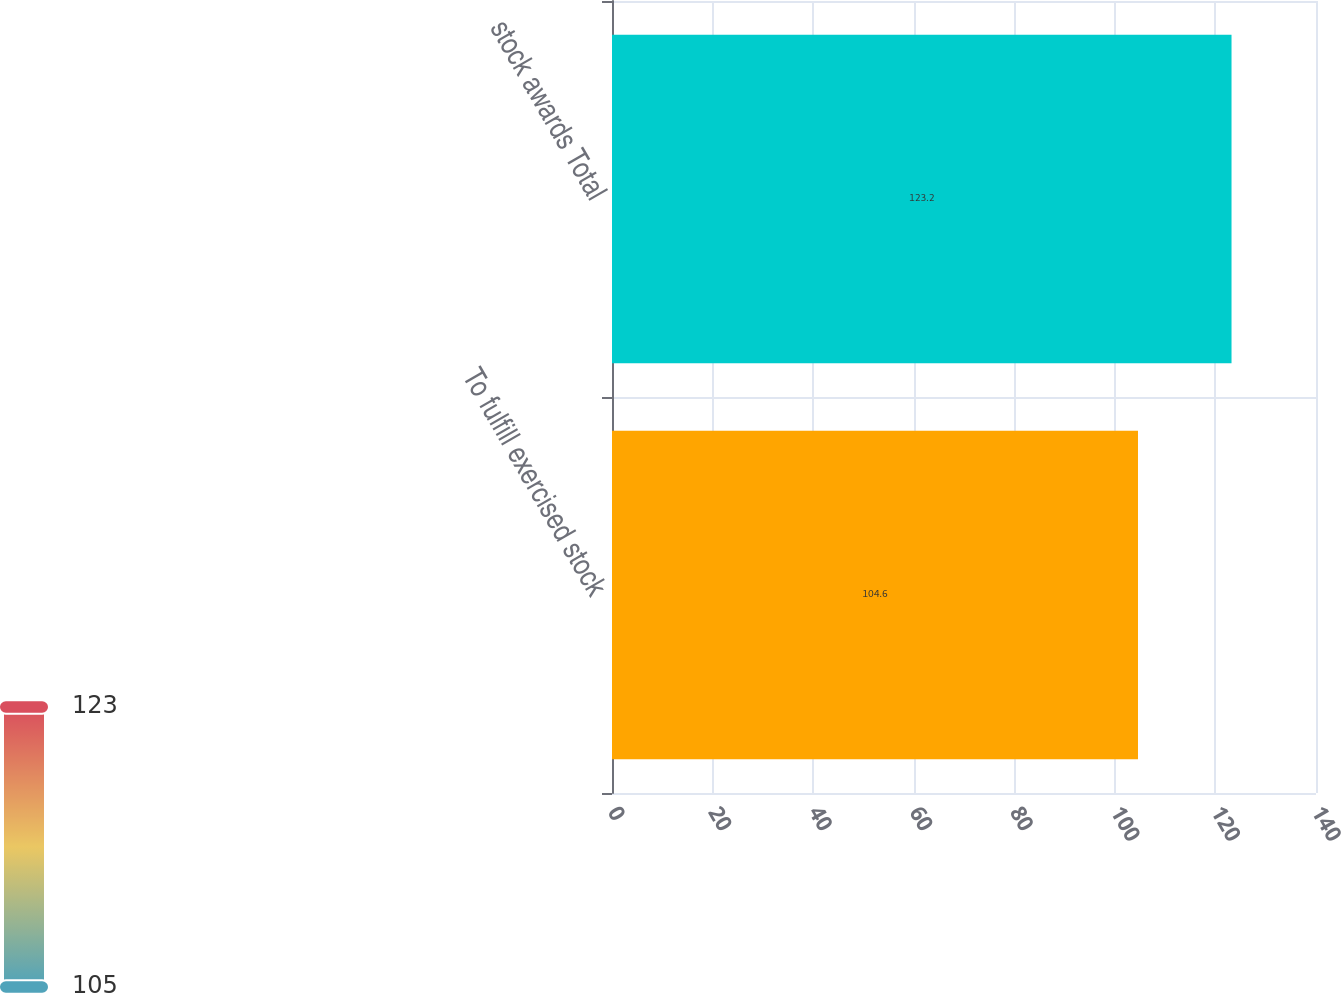Convert chart. <chart><loc_0><loc_0><loc_500><loc_500><bar_chart><fcel>To fulfill exercised stock<fcel>stock awards Total<nl><fcel>104.6<fcel>123.2<nl></chart> 